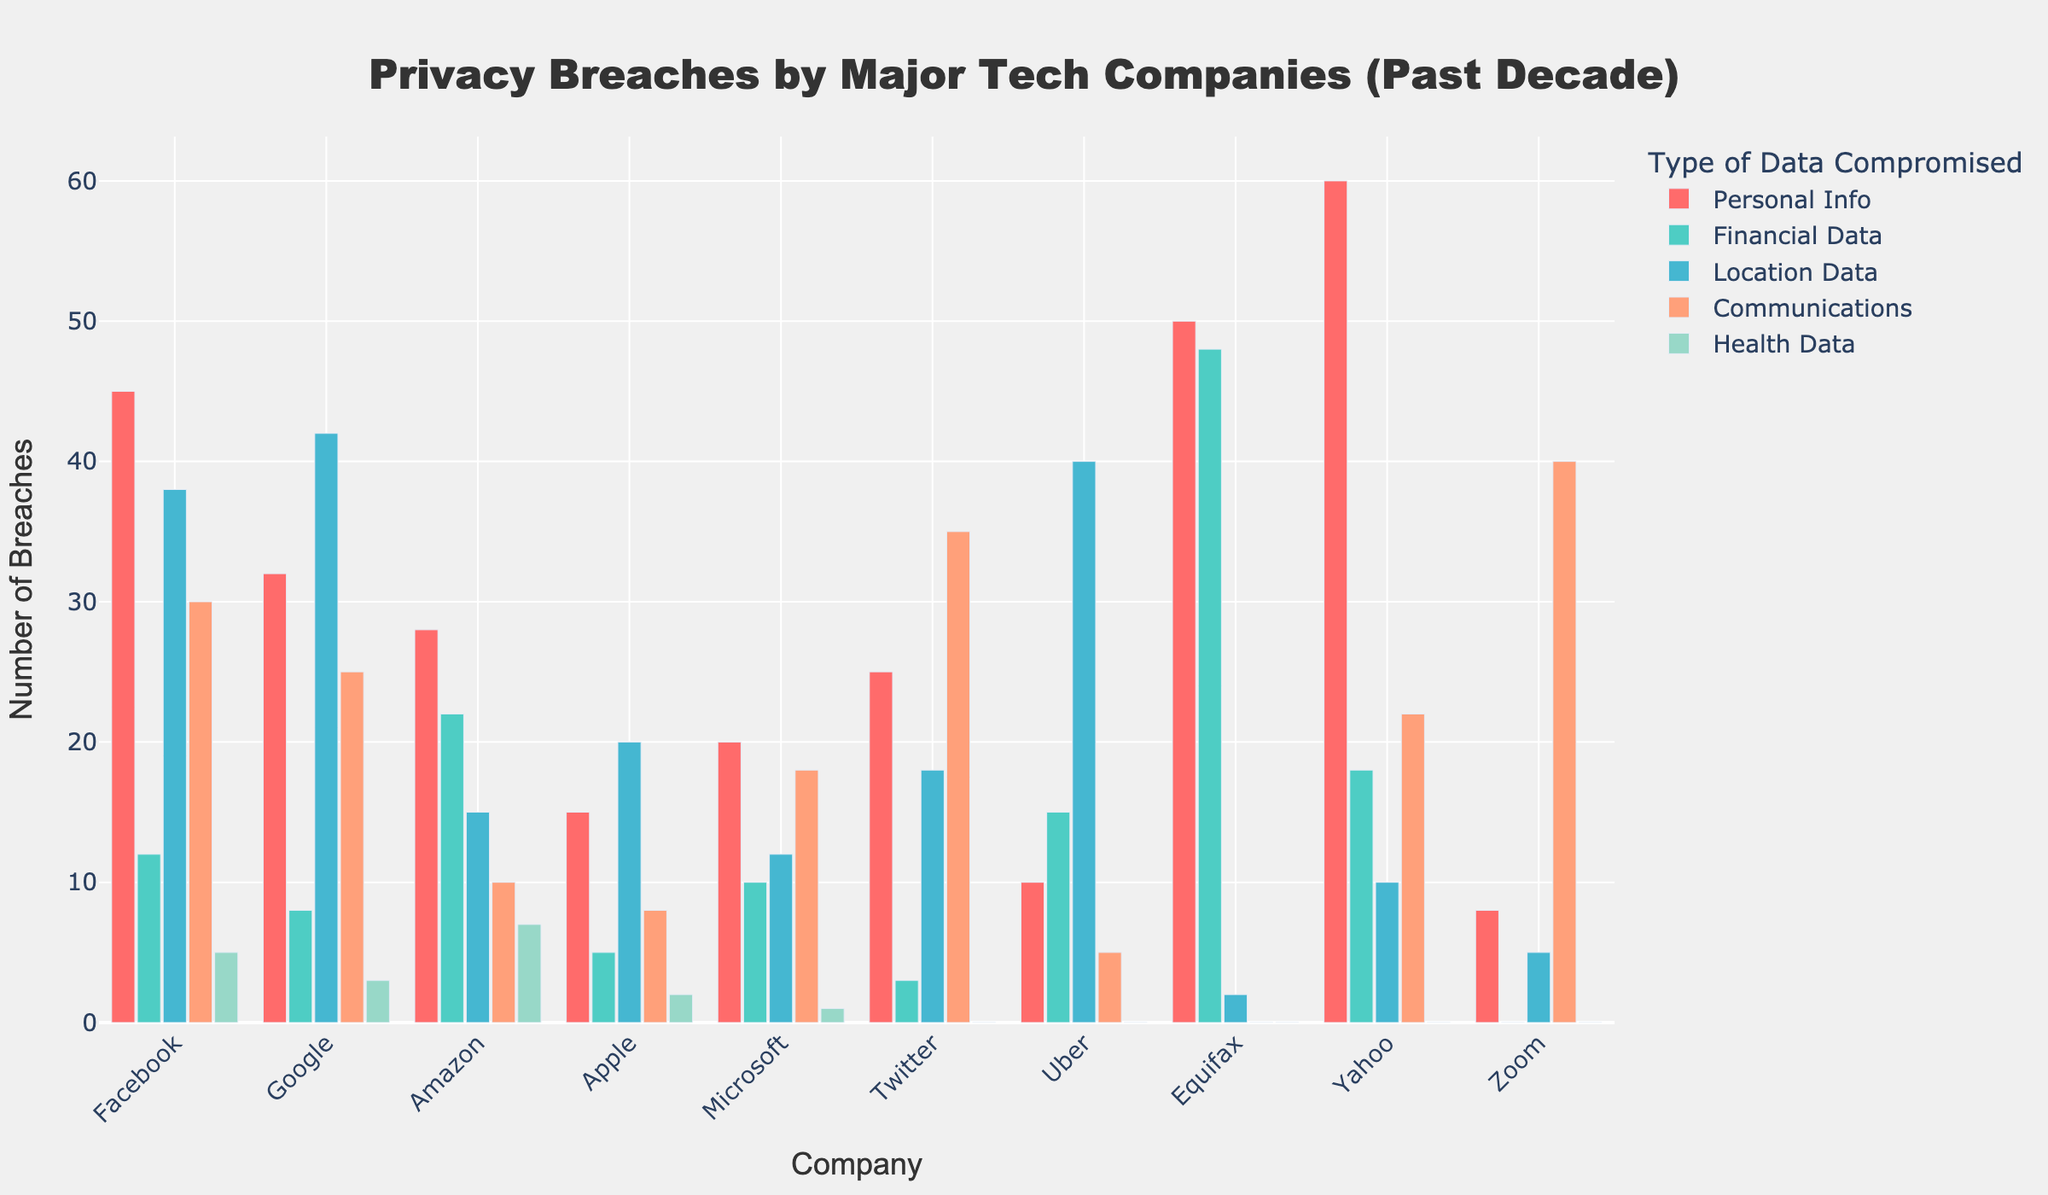What's the company with the most breaches in Personal Info? To find this, look at the bar heights for the 'Personal Info' category and identify the highest one. The tallest bar in the 'Personal Info' category belongs to Yahoo, indicating it has the highest number of breaches in this category.
Answer: Yahoo Which type of data did Uber have the highest number of breaches in? Examine Uber's bars for each data type and identify the one with the largest value. The 'Location Data' category has the highest bar for Uber, meaning this is where Uber had the most breaches.
Answer: Location Data How does Facebook compare to Google in terms of breaches in Financial Data and Location Data? Compare the heights of the bars for Financial Data and Location Data for both Facebook and Google. Facebook has 12 breaches in Financial Data, and Google has 8; Facebook has fewer breaches in Location Data (38) compared to Google (42).
Answer: More in Financial Data, fewer in Location Data Which tech company experienced the least breaches in Health Data? Check the bars for the 'Health Data' category. Several companies (Twitter, Uber, Equifax, Yahoo, and Zoom) have bars of height 0 in this category, indicating they had no breaches in Health Data.
Answer: Twitter, Uber, Equifax, Yahoo, and Zoom What's the total number of breaches in Communication data for Twitter and Zoom combined? Add the values of the 'Communications' category bars for both Twitter and Zoom. Twitter has 35, and Zoom has 40, so the total is 35 + 40 = 75.
Answer: 75 Which company had the highest difference in breaches between Financial Data and Personal Info? Calculate the difference between Financial Data and Personal Info breaches for each company and identify the highest one. For Equifax: 50 - 48 = 2, this is the largest difference.
Answer: Equifax How many companies have breached over 20 instances of Location Data? Count the companies whose 'Location Data' bar heights are greater than 20. Facebook, Google, Uber have more than 20 breaches in Location Data.
Answer: 3 What is the average number of breaches in Financial Data among the companies? Sum the breaches in Financial Data for all companies and divide by the total number of companies. (12 + 8 + 22 + 5 + 10 + 3 + 15 + 48 + 18 + 0) / 10 = 141 / 10 = 14.1
Answer: 14.1 Which company had the most balanced breaches across all data types? Identify the company with the least variance among its breaches across the five categories, i.e., the bars should be closest in height. Microsoft has relatively balanced bars of breaches in Personal Info (20), Financial Data (10), Location Data (12), Communications (18), and Health Data (1).
Answer: Microsoft 